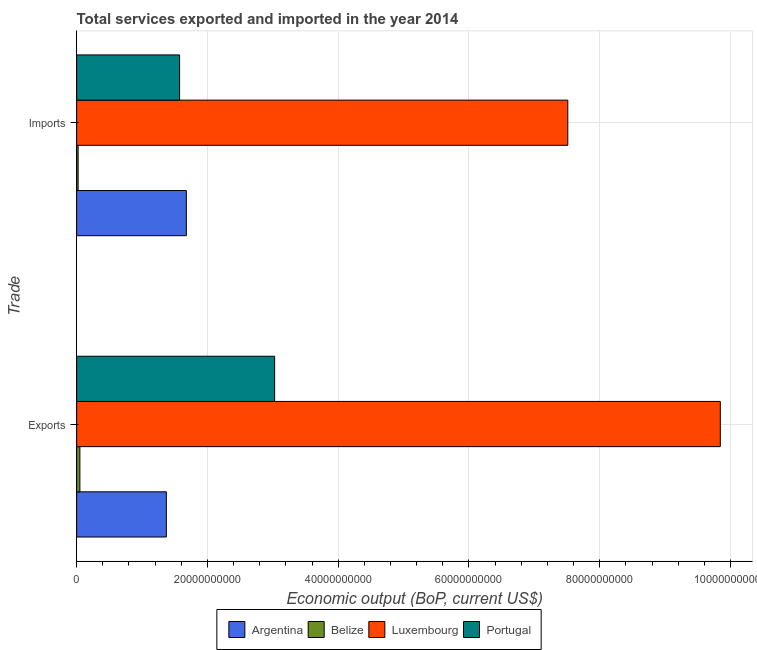How many different coloured bars are there?
Offer a very short reply. 4. How many bars are there on the 1st tick from the top?
Give a very brief answer. 4. How many bars are there on the 2nd tick from the bottom?
Ensure brevity in your answer.  4. What is the label of the 2nd group of bars from the top?
Keep it short and to the point. Exports. What is the amount of service imports in Luxembourg?
Your response must be concise. 7.51e+1. Across all countries, what is the maximum amount of service exports?
Give a very brief answer. 9.84e+1. Across all countries, what is the minimum amount of service exports?
Give a very brief answer. 4.94e+08. In which country was the amount of service imports maximum?
Keep it short and to the point. Luxembourg. In which country was the amount of service imports minimum?
Provide a succinct answer. Belize. What is the total amount of service exports in the graph?
Your answer should be compact. 1.43e+11. What is the difference between the amount of service imports in Belize and that in Argentina?
Provide a succinct answer. -1.66e+1. What is the difference between the amount of service imports in Argentina and the amount of service exports in Luxembourg?
Provide a short and direct response. -8.17e+1. What is the average amount of service imports per country?
Your response must be concise. 2.70e+1. What is the difference between the amount of service imports and amount of service exports in Portugal?
Your response must be concise. -1.45e+1. In how many countries, is the amount of service imports greater than 24000000000 US$?
Your answer should be very brief. 1. What is the ratio of the amount of service imports in Portugal to that in Belize?
Make the answer very short. 70.11. What does the 2nd bar from the top in Exports represents?
Keep it short and to the point. Luxembourg. Are all the bars in the graph horizontal?
Your response must be concise. Yes. What is the difference between two consecutive major ticks on the X-axis?
Your answer should be very brief. 2.00e+1. Does the graph contain grids?
Ensure brevity in your answer.  Yes. Where does the legend appear in the graph?
Your answer should be very brief. Bottom center. How many legend labels are there?
Your response must be concise. 4. How are the legend labels stacked?
Provide a short and direct response. Horizontal. What is the title of the graph?
Offer a terse response. Total services exported and imported in the year 2014. Does "Euro area" appear as one of the legend labels in the graph?
Provide a short and direct response. No. What is the label or title of the X-axis?
Ensure brevity in your answer.  Economic output (BoP, current US$). What is the label or title of the Y-axis?
Give a very brief answer. Trade. What is the Economic output (BoP, current US$) of Argentina in Exports?
Ensure brevity in your answer.  1.37e+1. What is the Economic output (BoP, current US$) in Belize in Exports?
Provide a short and direct response. 4.94e+08. What is the Economic output (BoP, current US$) of Luxembourg in Exports?
Your answer should be very brief. 9.84e+1. What is the Economic output (BoP, current US$) of Portugal in Exports?
Offer a very short reply. 3.03e+1. What is the Economic output (BoP, current US$) in Argentina in Imports?
Provide a short and direct response. 1.68e+1. What is the Economic output (BoP, current US$) in Belize in Imports?
Offer a very short reply. 2.25e+08. What is the Economic output (BoP, current US$) of Luxembourg in Imports?
Provide a succinct answer. 7.51e+1. What is the Economic output (BoP, current US$) in Portugal in Imports?
Ensure brevity in your answer.  1.57e+1. Across all Trade, what is the maximum Economic output (BoP, current US$) in Argentina?
Offer a terse response. 1.68e+1. Across all Trade, what is the maximum Economic output (BoP, current US$) of Belize?
Offer a very short reply. 4.94e+08. Across all Trade, what is the maximum Economic output (BoP, current US$) in Luxembourg?
Make the answer very short. 9.84e+1. Across all Trade, what is the maximum Economic output (BoP, current US$) of Portugal?
Ensure brevity in your answer.  3.03e+1. Across all Trade, what is the minimum Economic output (BoP, current US$) in Argentina?
Your response must be concise. 1.37e+1. Across all Trade, what is the minimum Economic output (BoP, current US$) of Belize?
Provide a short and direct response. 2.25e+08. Across all Trade, what is the minimum Economic output (BoP, current US$) of Luxembourg?
Make the answer very short. 7.51e+1. Across all Trade, what is the minimum Economic output (BoP, current US$) of Portugal?
Keep it short and to the point. 1.57e+1. What is the total Economic output (BoP, current US$) in Argentina in the graph?
Your response must be concise. 3.05e+1. What is the total Economic output (BoP, current US$) in Belize in the graph?
Your response must be concise. 7.19e+08. What is the total Economic output (BoP, current US$) of Luxembourg in the graph?
Give a very brief answer. 1.74e+11. What is the total Economic output (BoP, current US$) in Portugal in the graph?
Your response must be concise. 4.60e+1. What is the difference between the Economic output (BoP, current US$) of Argentina in Exports and that in Imports?
Ensure brevity in your answer.  -3.06e+09. What is the difference between the Economic output (BoP, current US$) of Belize in Exports and that in Imports?
Ensure brevity in your answer.  2.70e+08. What is the difference between the Economic output (BoP, current US$) in Luxembourg in Exports and that in Imports?
Offer a terse response. 2.33e+1. What is the difference between the Economic output (BoP, current US$) in Portugal in Exports and that in Imports?
Offer a very short reply. 1.45e+1. What is the difference between the Economic output (BoP, current US$) of Argentina in Exports and the Economic output (BoP, current US$) of Belize in Imports?
Offer a very short reply. 1.35e+1. What is the difference between the Economic output (BoP, current US$) of Argentina in Exports and the Economic output (BoP, current US$) of Luxembourg in Imports?
Offer a very short reply. -6.14e+1. What is the difference between the Economic output (BoP, current US$) in Argentina in Exports and the Economic output (BoP, current US$) in Portugal in Imports?
Your answer should be very brief. -2.03e+09. What is the difference between the Economic output (BoP, current US$) in Belize in Exports and the Economic output (BoP, current US$) in Luxembourg in Imports?
Provide a succinct answer. -7.46e+1. What is the difference between the Economic output (BoP, current US$) of Belize in Exports and the Economic output (BoP, current US$) of Portugal in Imports?
Keep it short and to the point. -1.53e+1. What is the difference between the Economic output (BoP, current US$) in Luxembourg in Exports and the Economic output (BoP, current US$) in Portugal in Imports?
Make the answer very short. 8.27e+1. What is the average Economic output (BoP, current US$) in Argentina per Trade?
Your answer should be compact. 1.52e+1. What is the average Economic output (BoP, current US$) of Belize per Trade?
Make the answer very short. 3.59e+08. What is the average Economic output (BoP, current US$) in Luxembourg per Trade?
Make the answer very short. 8.68e+1. What is the average Economic output (BoP, current US$) in Portugal per Trade?
Give a very brief answer. 2.30e+1. What is the difference between the Economic output (BoP, current US$) of Argentina and Economic output (BoP, current US$) of Belize in Exports?
Provide a short and direct response. 1.32e+1. What is the difference between the Economic output (BoP, current US$) of Argentina and Economic output (BoP, current US$) of Luxembourg in Exports?
Keep it short and to the point. -8.47e+1. What is the difference between the Economic output (BoP, current US$) in Argentina and Economic output (BoP, current US$) in Portugal in Exports?
Provide a short and direct response. -1.66e+1. What is the difference between the Economic output (BoP, current US$) of Belize and Economic output (BoP, current US$) of Luxembourg in Exports?
Give a very brief answer. -9.79e+1. What is the difference between the Economic output (BoP, current US$) of Belize and Economic output (BoP, current US$) of Portugal in Exports?
Provide a short and direct response. -2.98e+1. What is the difference between the Economic output (BoP, current US$) of Luxembourg and Economic output (BoP, current US$) of Portugal in Exports?
Keep it short and to the point. 6.82e+1. What is the difference between the Economic output (BoP, current US$) of Argentina and Economic output (BoP, current US$) of Belize in Imports?
Provide a short and direct response. 1.66e+1. What is the difference between the Economic output (BoP, current US$) of Argentina and Economic output (BoP, current US$) of Luxembourg in Imports?
Your answer should be compact. -5.83e+1. What is the difference between the Economic output (BoP, current US$) in Argentina and Economic output (BoP, current US$) in Portugal in Imports?
Your answer should be compact. 1.03e+09. What is the difference between the Economic output (BoP, current US$) of Belize and Economic output (BoP, current US$) of Luxembourg in Imports?
Your answer should be very brief. -7.49e+1. What is the difference between the Economic output (BoP, current US$) in Belize and Economic output (BoP, current US$) in Portugal in Imports?
Make the answer very short. -1.55e+1. What is the difference between the Economic output (BoP, current US$) in Luxembourg and Economic output (BoP, current US$) in Portugal in Imports?
Offer a terse response. 5.94e+1. What is the ratio of the Economic output (BoP, current US$) of Argentina in Exports to that in Imports?
Your answer should be compact. 0.82. What is the ratio of the Economic output (BoP, current US$) in Belize in Exports to that in Imports?
Your answer should be compact. 2.2. What is the ratio of the Economic output (BoP, current US$) of Luxembourg in Exports to that in Imports?
Ensure brevity in your answer.  1.31. What is the ratio of the Economic output (BoP, current US$) of Portugal in Exports to that in Imports?
Make the answer very short. 1.92. What is the difference between the highest and the second highest Economic output (BoP, current US$) of Argentina?
Your response must be concise. 3.06e+09. What is the difference between the highest and the second highest Economic output (BoP, current US$) in Belize?
Offer a very short reply. 2.70e+08. What is the difference between the highest and the second highest Economic output (BoP, current US$) in Luxembourg?
Your answer should be compact. 2.33e+1. What is the difference between the highest and the second highest Economic output (BoP, current US$) of Portugal?
Give a very brief answer. 1.45e+1. What is the difference between the highest and the lowest Economic output (BoP, current US$) in Argentina?
Provide a short and direct response. 3.06e+09. What is the difference between the highest and the lowest Economic output (BoP, current US$) of Belize?
Offer a very short reply. 2.70e+08. What is the difference between the highest and the lowest Economic output (BoP, current US$) in Luxembourg?
Ensure brevity in your answer.  2.33e+1. What is the difference between the highest and the lowest Economic output (BoP, current US$) in Portugal?
Your answer should be very brief. 1.45e+1. 